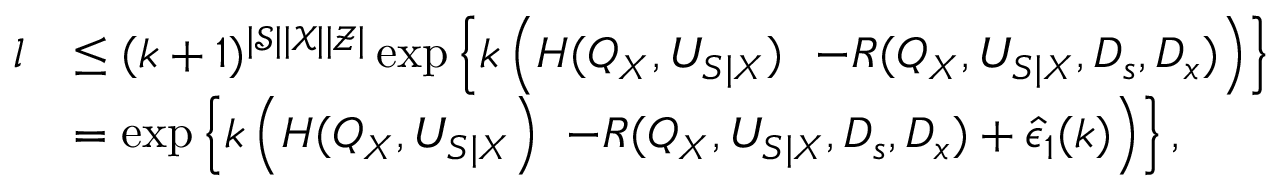Convert formula to latex. <formula><loc_0><loc_0><loc_500><loc_500>\begin{array} { r l } { l } & { \leq ( k + 1 ) ^ { | \mathcal { S } | | \mathcal { X } | | \mathcal { Z } | } \exp \left \{ k \left ( H ( Q _ { X } , U _ { S | X } ) - R ( Q _ { X } , U _ { S | X } , D _ { s } , D _ { x } ) \right ) \right \} } \\ & { = \exp \left \{ k \left ( H ( Q _ { X } , U _ { S | X } \right ) - R ( Q _ { X } , U _ { S | X } , D _ { s } , D _ { x } ) + \hat { \epsilon } _ { 1 } ( k ) \right ) \right \} , } \end{array}</formula> 